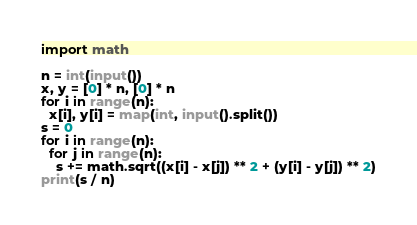<code> <loc_0><loc_0><loc_500><loc_500><_Python_>import math

n = int(input())
x, y = [0] * n, [0] * n
for i in range(n):
  x[i], y[i] = map(int, input().split())
s = 0
for i in range(n):
  for j in range(n):
    s += math.sqrt((x[i] - x[j]) ** 2 + (y[i] - y[j]) ** 2)
print(s / n)</code> 